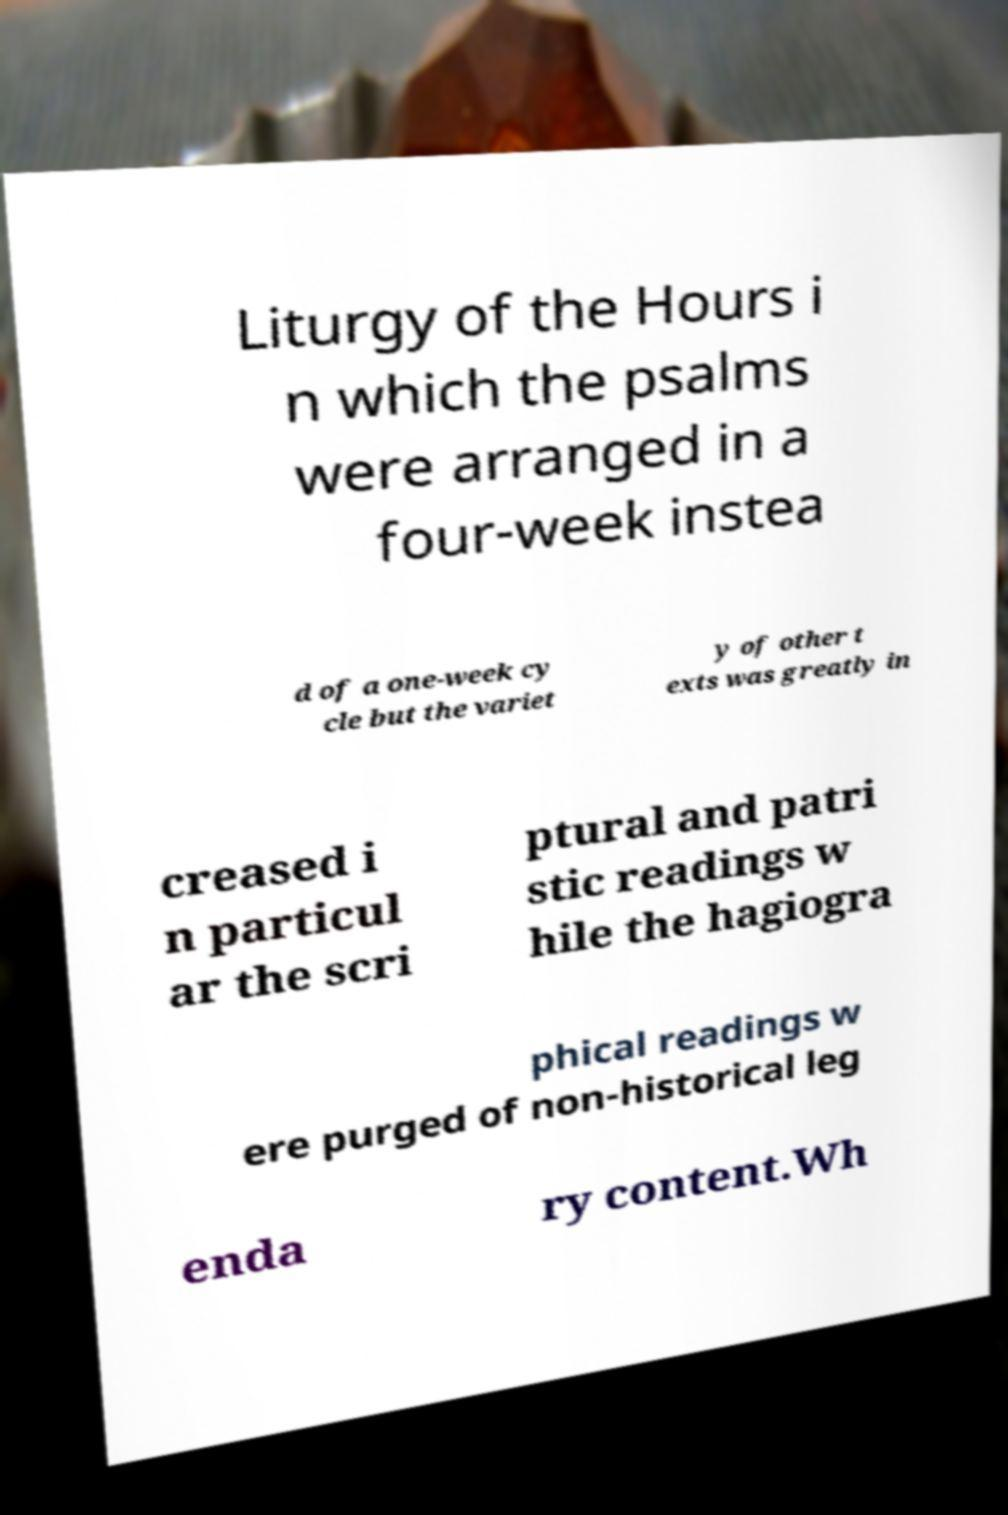Could you assist in decoding the text presented in this image and type it out clearly? Liturgy of the Hours i n which the psalms were arranged in a four-week instea d of a one-week cy cle but the variet y of other t exts was greatly in creased i n particul ar the scri ptural and patri stic readings w hile the hagiogra phical readings w ere purged of non-historical leg enda ry content.Wh 